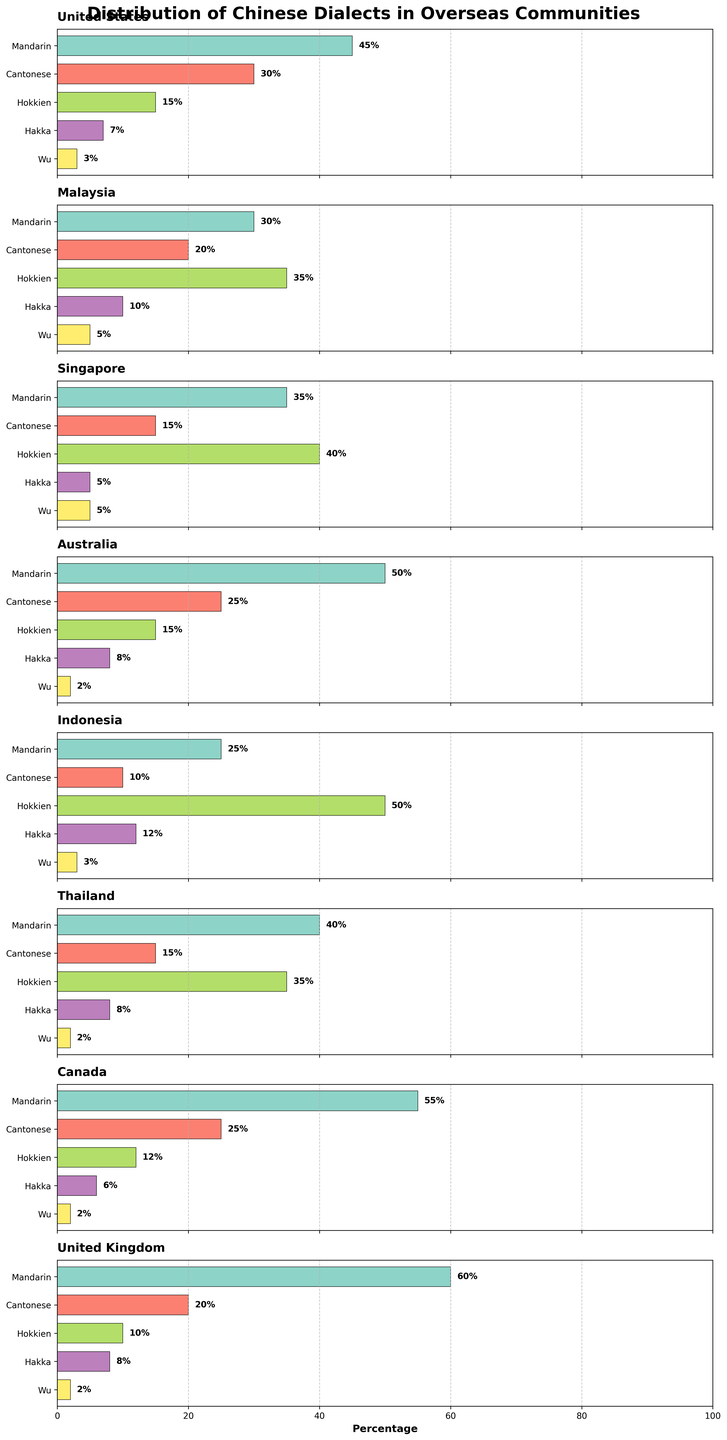What's the title of the figure? The figure's title is typically placed at the top in bold and larger font size. It's meant to give an overall description of what the visualization represents.
Answer: Distribution of Chinese Dialects in Overseas Communities Which country has the highest percentage of Mandarin speakers? By examining the bar heights corresponding to 'Mandarin' for all countries, the United Kingdom has the longest bar, indicating the highest percentage.
Answer: United Kingdom In which country is Hokkien the most prevalent? We compare the heights of the 'Hokkien' bars across all subplots. Indonesia has the longest bar, thus has the highest percentage of Hokkien speakers.
Answer: Indonesia What is the total percentage of Cantonese and Hakka speakers in Australia? We add the height of the 'Cantonese' bar and the 'Hakka' bar in the Australia subplot. Cantonese is 25% and Hakka is 8%, so their sum is 25% + 8% = 33%.
Answer: 33% Which Chinese dialect is least spoken in Singapore? By observing the bars in the Singapore subplot, we see that Hakka has the shortest bar at 5%, indicating it is the least spoken dialect.
Answer: Hakka How does the percentage of Wu speakers in Canada compare to Thailand? By comparing the 'Wu' bars for Canada and Thailand, we see both are at 2%, thus they are equal.
Answer: Equal Which country has the smallest proportion of Hakka speakers? We compare the 'Hakka' bars for all countries. Canada has the shortest bar, indicating the smallest proportion at 6%.
Answer: Canada What is the difference in the percentage of Hokkien speakers between the United States and Malaysia? We find the 'Hokkien' percentages for both countries and subtract the smaller from the larger: 35% (Malaysia) - 15% (United States) = 20%.
Answer: 20% Which two countries have the closest percentage of Mandarin speakers? By comparing Mandarin percentages for all countries, we notice Australia (50%) and the United States (45%) are closest, with only a 5% difference.
Answer: Australia and United States What is the average percentage of Cantonese speakers across all countries? We sum the Cantonese percentages from all countries and divide by the number of countries: (30 + 20 + 15 + 25 + 10 + 15 + 25 + 20) / 8 = 20%.
Answer: 20% 